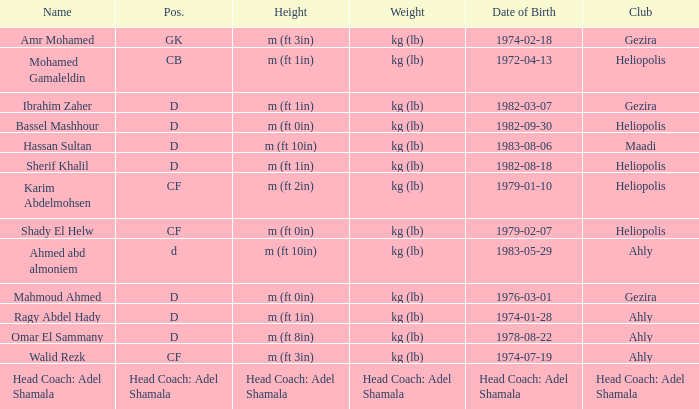What is the heaviness when the club is "maadi"? Kg (lb). 